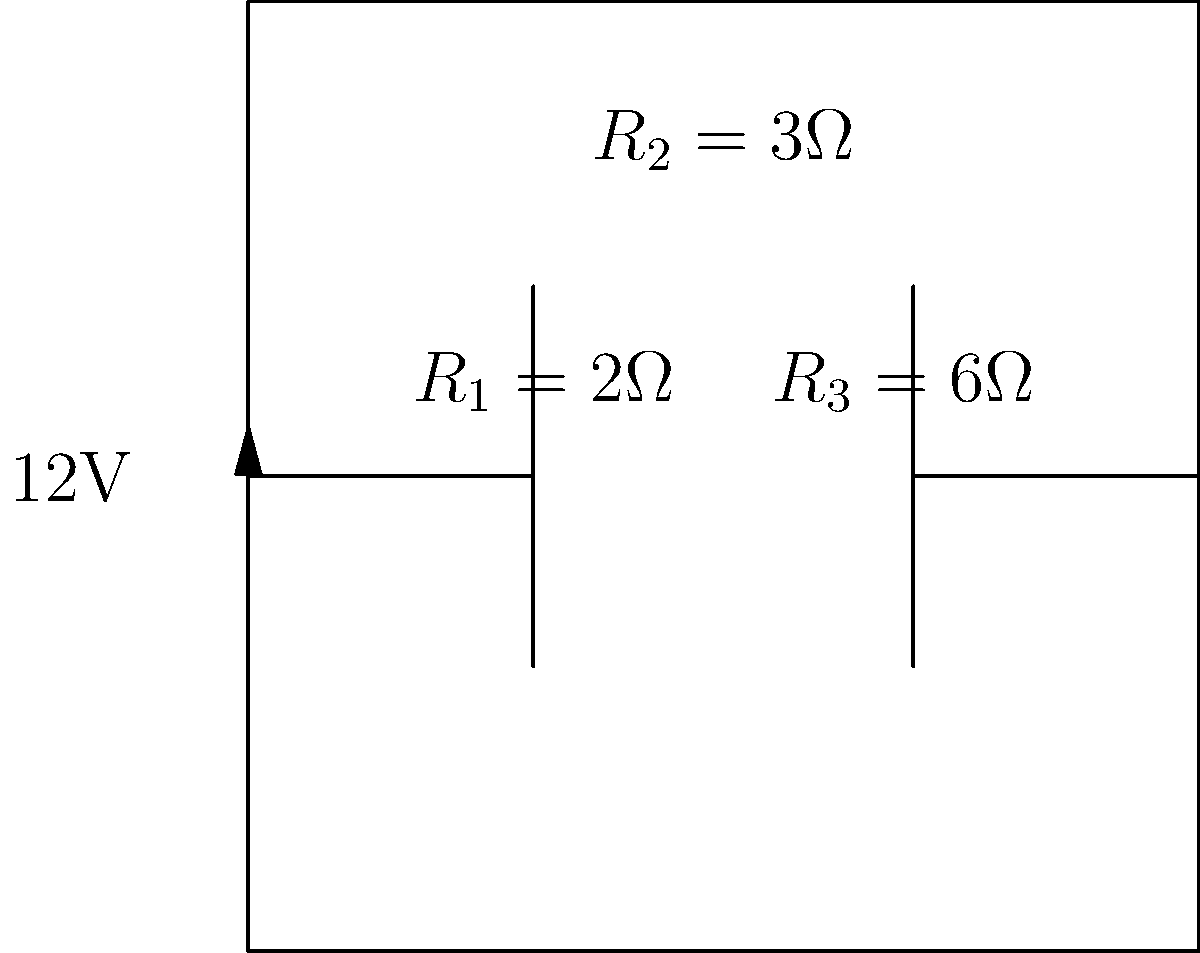As a parent volunteer helping in a science class, you're assisting students with an electrical engineering problem. Given the circuit diagram above, calculate the total resistance of the circuit. Assume all connections are ideal. Let's approach this step-by-step:

1) First, we identify the arrangement of resistors:
   - $R_1$ and $R_3$ are in parallel with each other
   - This parallel combination is in series with $R_2$

2) Let's calculate the equivalent resistance of the parallel combination of $R_1$ and $R_3$:
   $\frac{1}{R_{eq}} = \frac{1}{R_1} + \frac{1}{R_3}$
   $\frac{1}{R_{eq}} = \frac{1}{2} + \frac{1}{6} = \frac{3}{6} + \frac{1}{6} = \frac{4}{6} = \frac{2}{3}$
   $R_{eq} = \frac{3}{2} = 1.5\Omega$

3) Now we have this equivalent resistance in series with $R_2$:
   $R_{total} = R_{eq} + R_2 = 1.5\Omega + 3\Omega = 4.5\Omega$

Therefore, the total resistance of the circuit is 4.5Ω.
Answer: $4.5\Omega$ 